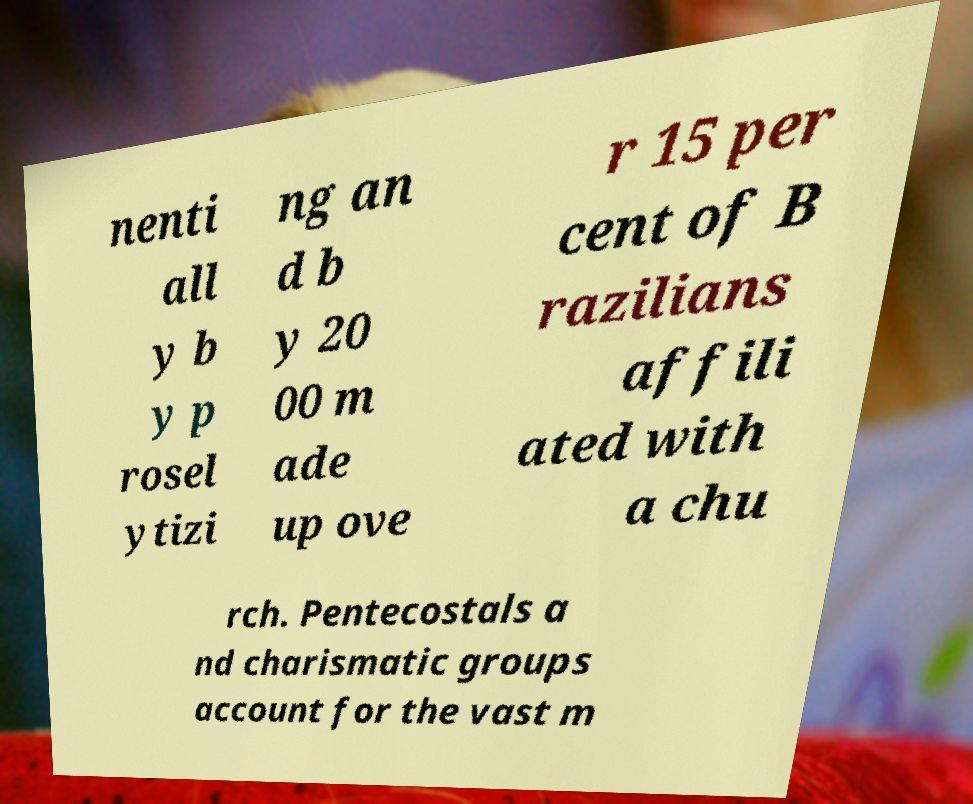Can you accurately transcribe the text from the provided image for me? nenti all y b y p rosel ytizi ng an d b y 20 00 m ade up ove r 15 per cent of B razilians affili ated with a chu rch. Pentecostals a nd charismatic groups account for the vast m 